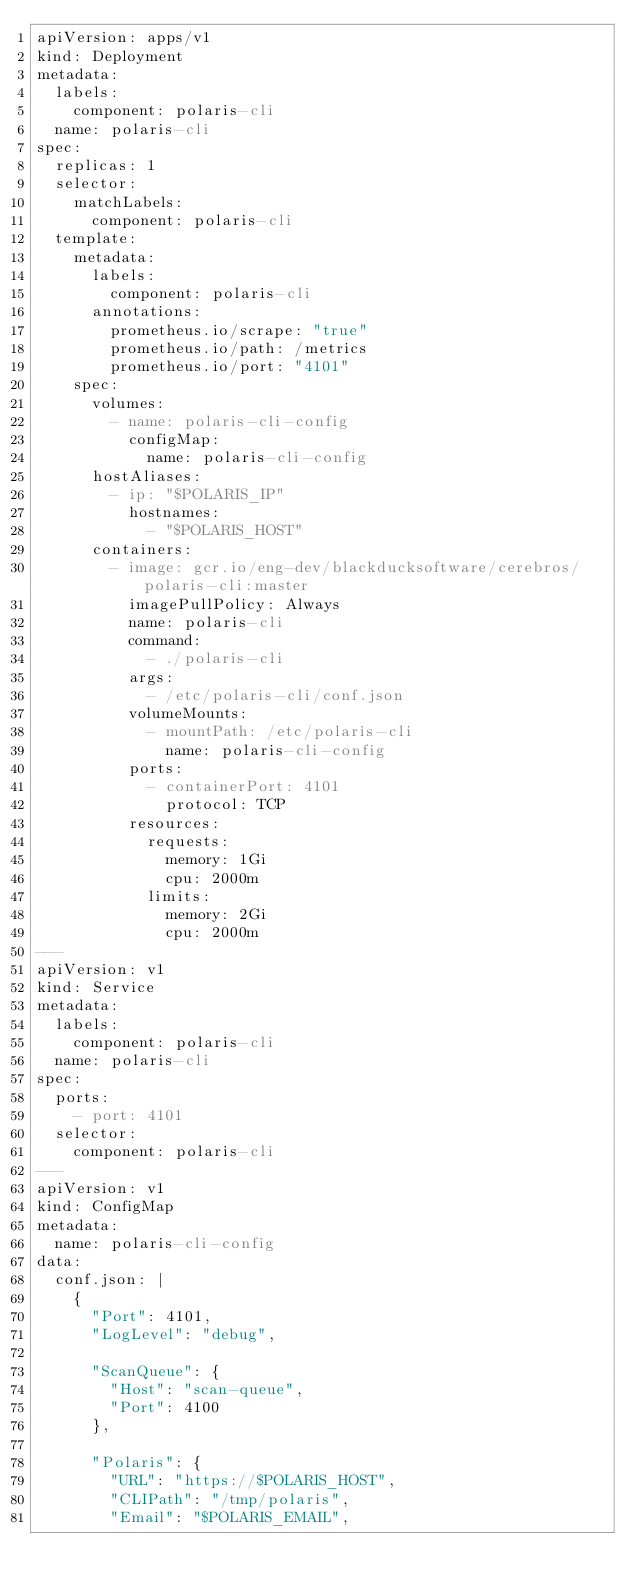Convert code to text. <code><loc_0><loc_0><loc_500><loc_500><_YAML_>apiVersion: apps/v1
kind: Deployment
metadata:
  labels:
    component: polaris-cli
  name: polaris-cli
spec:
  replicas: 1
  selector:
    matchLabels:
      component: polaris-cli
  template:
    metadata:
      labels:
        component: polaris-cli
      annotations:
        prometheus.io/scrape: "true"
        prometheus.io/path: /metrics
        prometheus.io/port: "4101"
    spec:
      volumes:
        - name: polaris-cli-config
          configMap:
            name: polaris-cli-config
      hostAliases:
        - ip: "$POLARIS_IP"
          hostnames:
            - "$POLARIS_HOST"
      containers:
        - image: gcr.io/eng-dev/blackducksoftware/cerebros/polaris-cli:master
          imagePullPolicy: Always
          name: polaris-cli
          command:
            - ./polaris-cli
          args:
            - /etc/polaris-cli/conf.json
          volumeMounts:
            - mountPath: /etc/polaris-cli
              name: polaris-cli-config
          ports:
            - containerPort: 4101
              protocol: TCP
          resources:
            requests:
              memory: 1Gi
              cpu: 2000m
            limits:
              memory: 2Gi
              cpu: 2000m
---
apiVersion: v1
kind: Service
metadata:
  labels:
    component: polaris-cli
  name: polaris-cli
spec:
  ports:
    - port: 4101
  selector:
    component: polaris-cli
---
apiVersion: v1
kind: ConfigMap
metadata:
  name: polaris-cli-config
data:
  conf.json: |
    {
      "Port": 4101,
      "LogLevel": "debug",

      "ScanQueue": {
        "Host": "scan-queue",
        "Port": 4100
      },

      "Polaris": {
        "URL": "https://$POLARIS_HOST",
        "CLIPath": "/tmp/polaris",
        "Email": "$POLARIS_EMAIL",</code> 